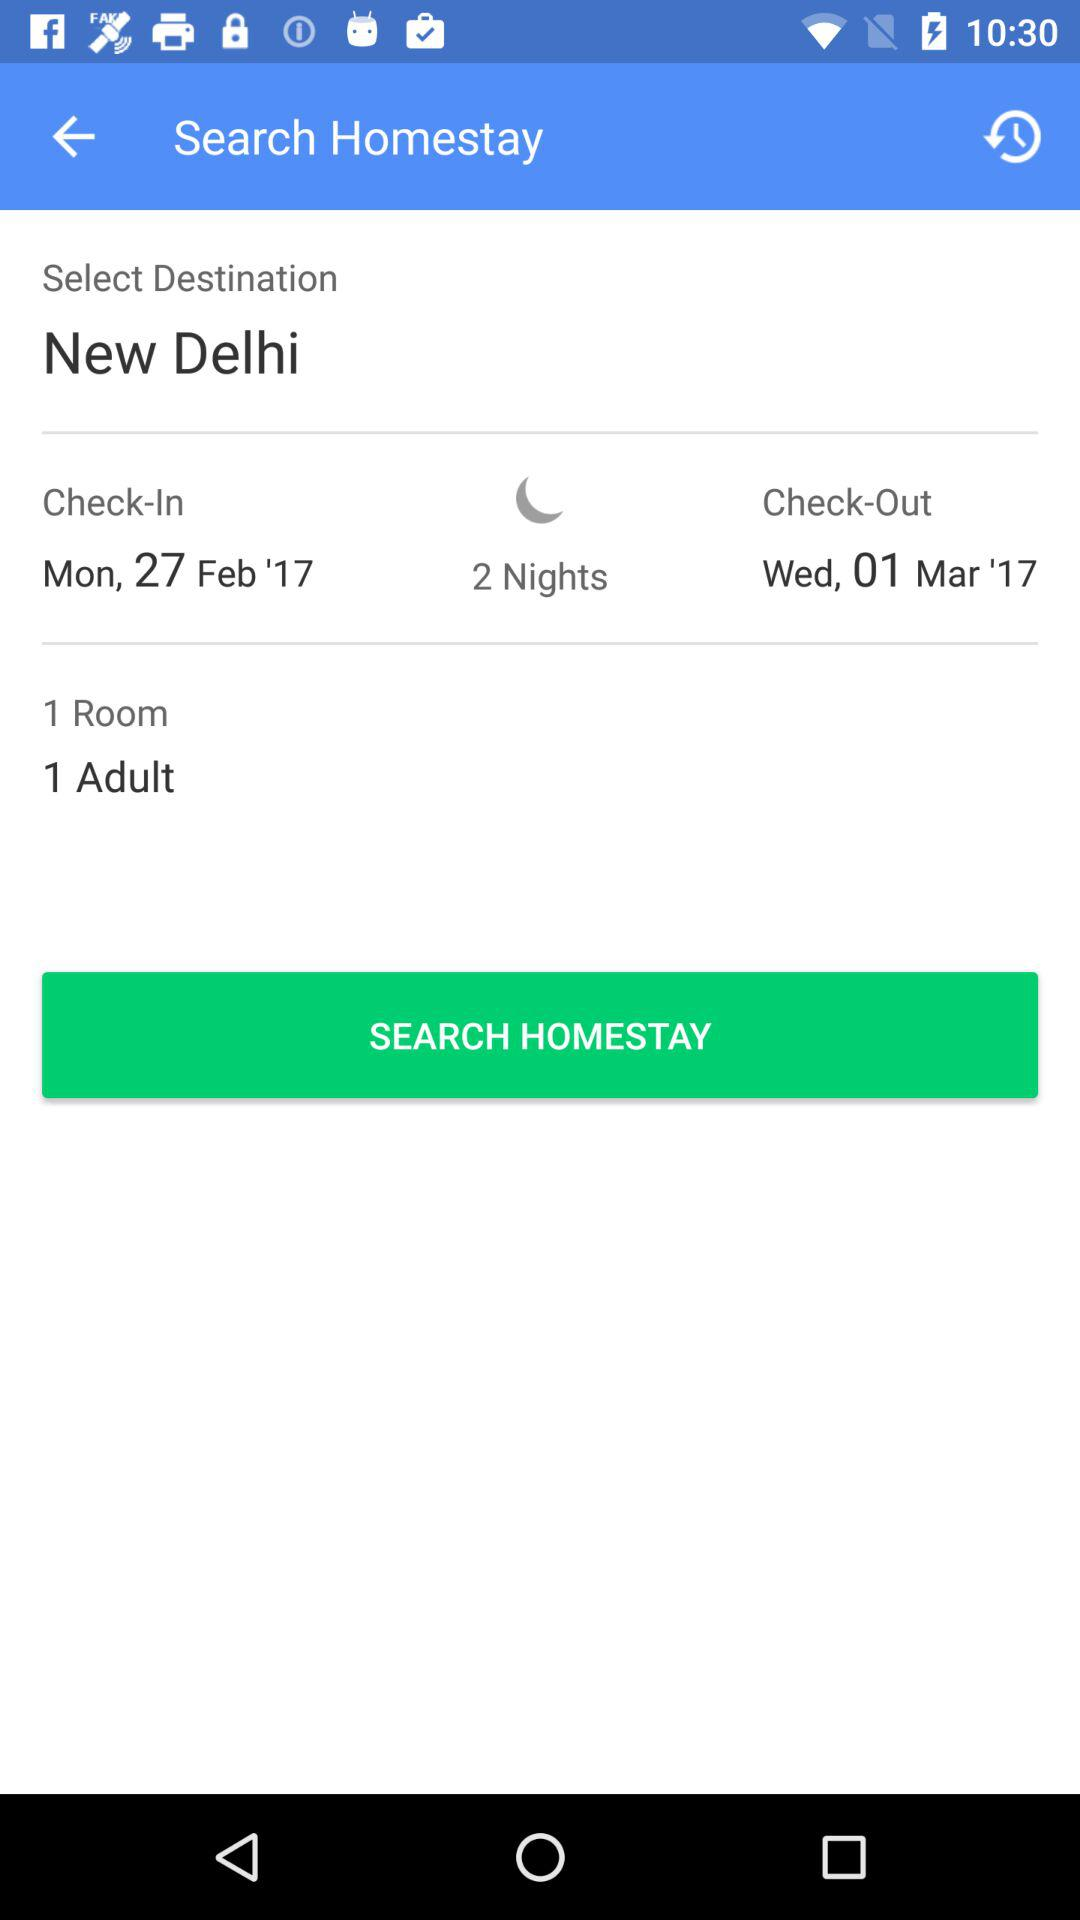How many adults are staying?
Answer the question using a single word or phrase. 1 